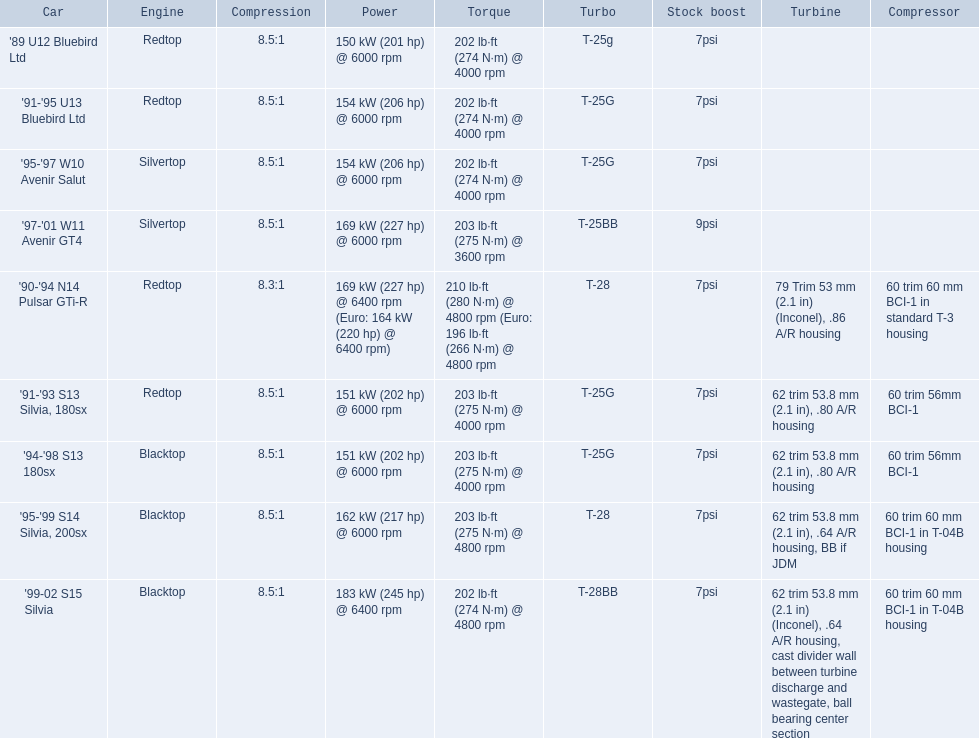What are all of the cars? '89 U12 Bluebird Ltd, '91-'95 U13 Bluebird Ltd, '95-'97 W10 Avenir Salut, '97-'01 W11 Avenir GT4, '90-'94 N14 Pulsar GTi-R, '91-'93 S13 Silvia, 180sx, '94-'98 S13 180sx, '95-'99 S14 Silvia, 200sx, '99-02 S15 Silvia. What is their rated power? 150 kW (201 hp) @ 6000 rpm, 154 kW (206 hp) @ 6000 rpm, 154 kW (206 hp) @ 6000 rpm, 169 kW (227 hp) @ 6000 rpm, 169 kW (227 hp) @ 6400 rpm (Euro: 164 kW (220 hp) @ 6400 rpm), 151 kW (202 hp) @ 6000 rpm, 151 kW (202 hp) @ 6000 rpm, 162 kW (217 hp) @ 6000 rpm, 183 kW (245 hp) @ 6400 rpm. Which car has the most power? '99-02 S15 Silvia. 